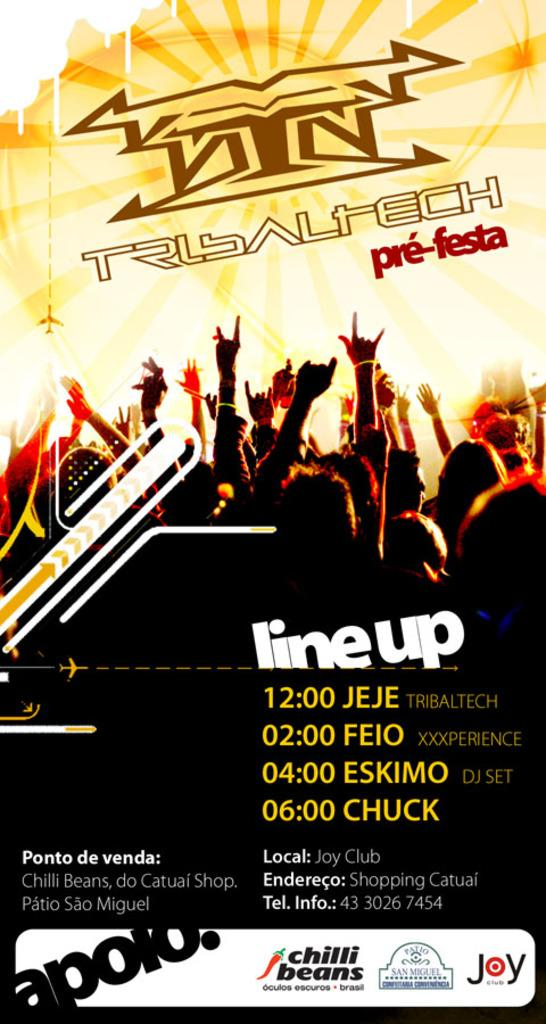<image>
Share a concise interpretation of the image provided. A concert promotional poster giving the lineup for a show at the Joy Club. 